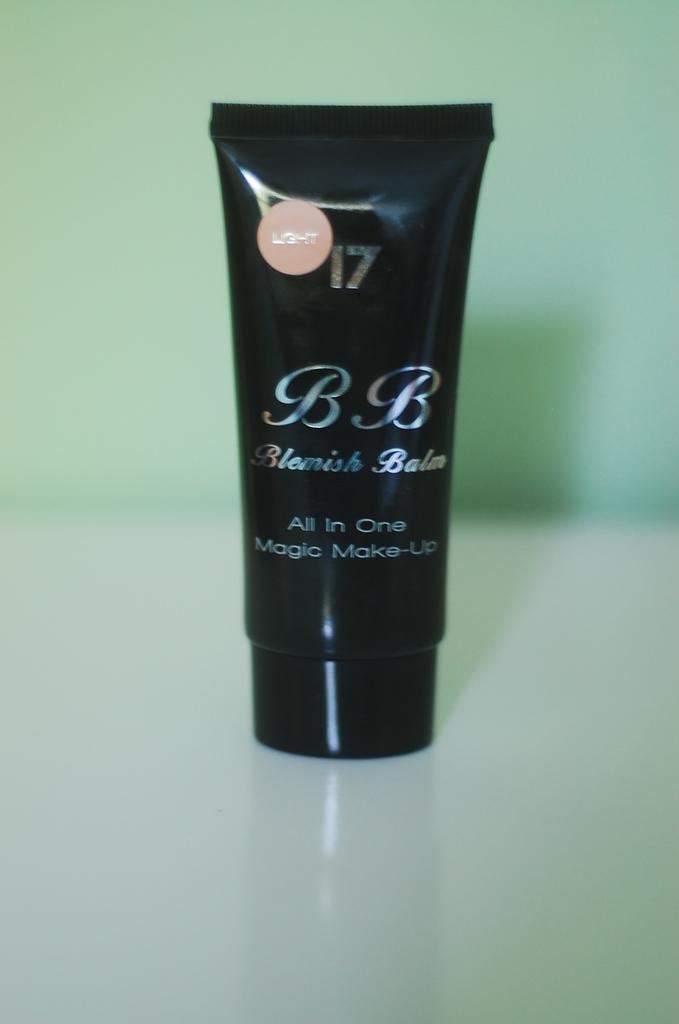<image>
Present a compact description of the photo's key features. A black bottle of make up named Blemish Balm is on the table. 